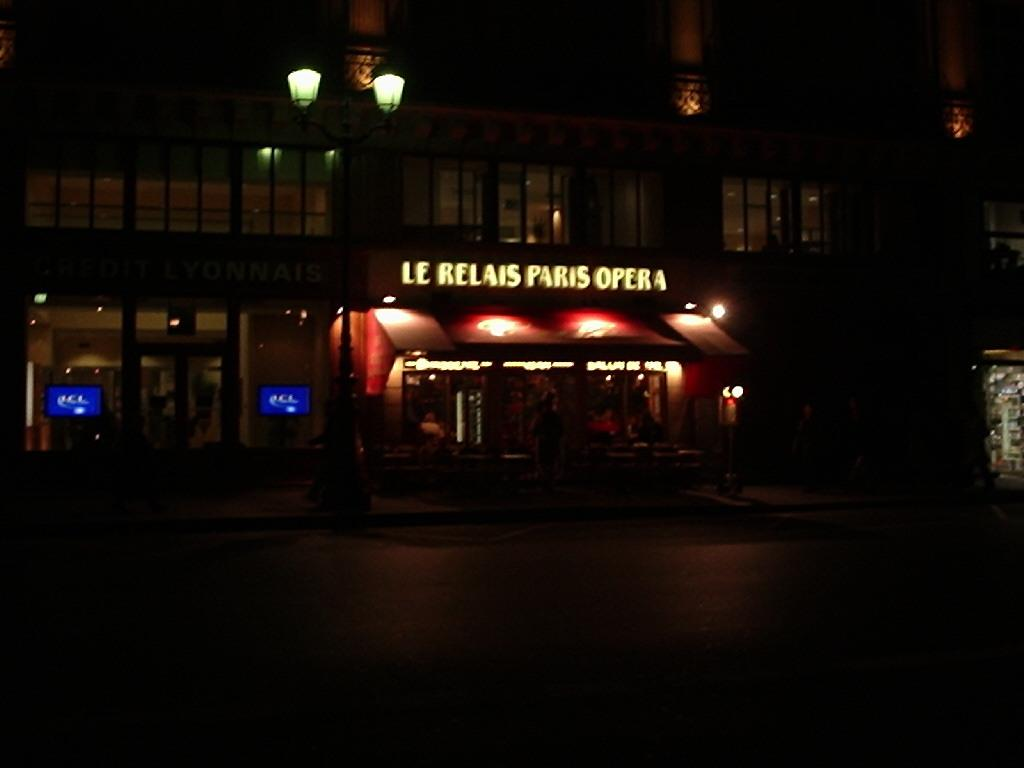What type of structure is present in the image? There is a building in the image. What can be seen through the glass of the building? Televisions are visible through the glass. Is there anyone present in the image? Yes, there is a man standing in the image. How is the building illuminated? The building has lights. What other feature with lights can be seen in the image? There is a name board with lights in the image. Can you tell me how many keys are hanging on the nail in the image? There is no nail or key present in the image. 